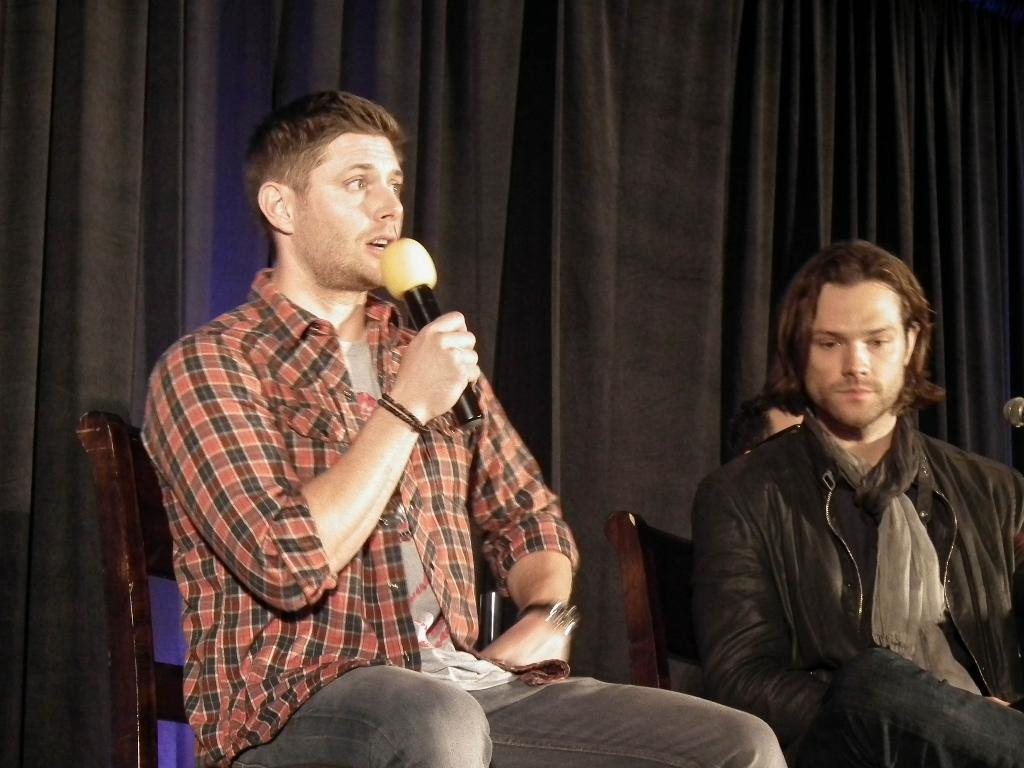What is the man in the image doing? The man is standing on a chair and talking on a microphone. Is there anyone else in the image doing a similar activity? Yes, there is another man standing on a chair beside the first man. What can be seen in the background of the image? There is a black cloth curtain in the background. How many minutes does the toad take to jump across the stage in the image? There is no toad present in the image, so it is not possible to determine how long it would take for a toad to jump across the stage. 